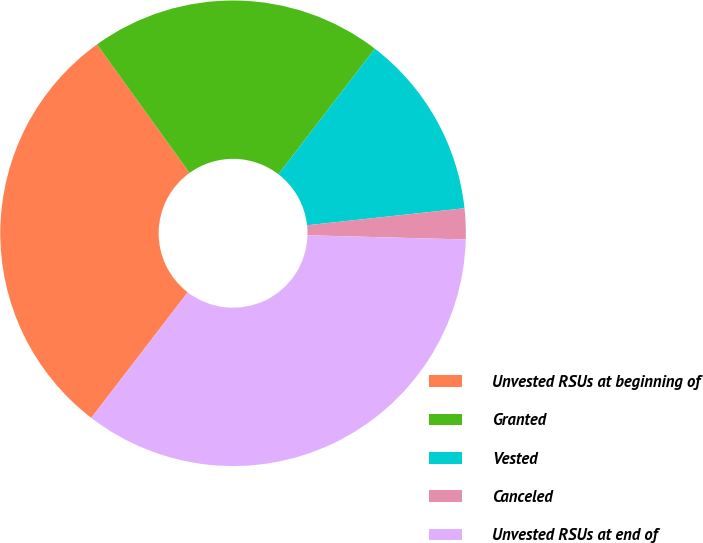Convert chart. <chart><loc_0><loc_0><loc_500><loc_500><pie_chart><fcel>Unvested RSUs at beginning of<fcel>Granted<fcel>Vested<fcel>Canceled<fcel>Unvested RSUs at end of<nl><fcel>29.64%<fcel>20.36%<fcel>12.86%<fcel>2.14%<fcel>35.0%<nl></chart> 